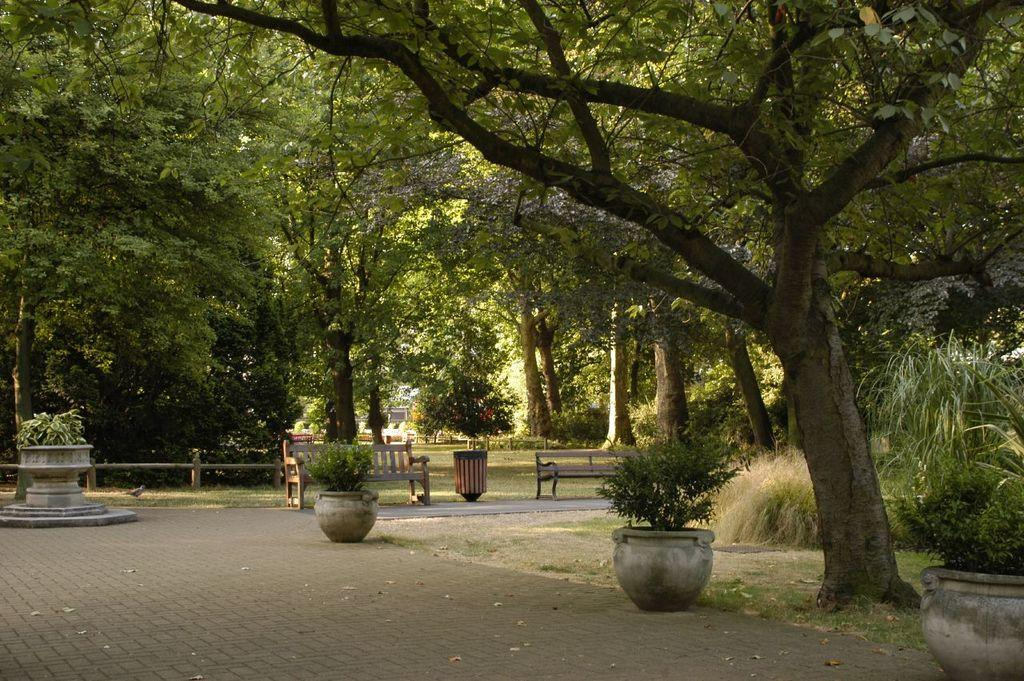What type of outdoor area is shown in the image? The image depicts a lawn. Are there any specific features on the right side of the lawn? Yes, there is a walking path on the right side. What can be found on the lawn for people to sit and relax? There are tables to sit in the image. What type of vegetation is present in the area? The area is covered with many trees. What type of stew is being served at the dinner table in the image? There is no dinner table or stew present in the image; it depicts a lawn with a walking path, tables, and trees. 